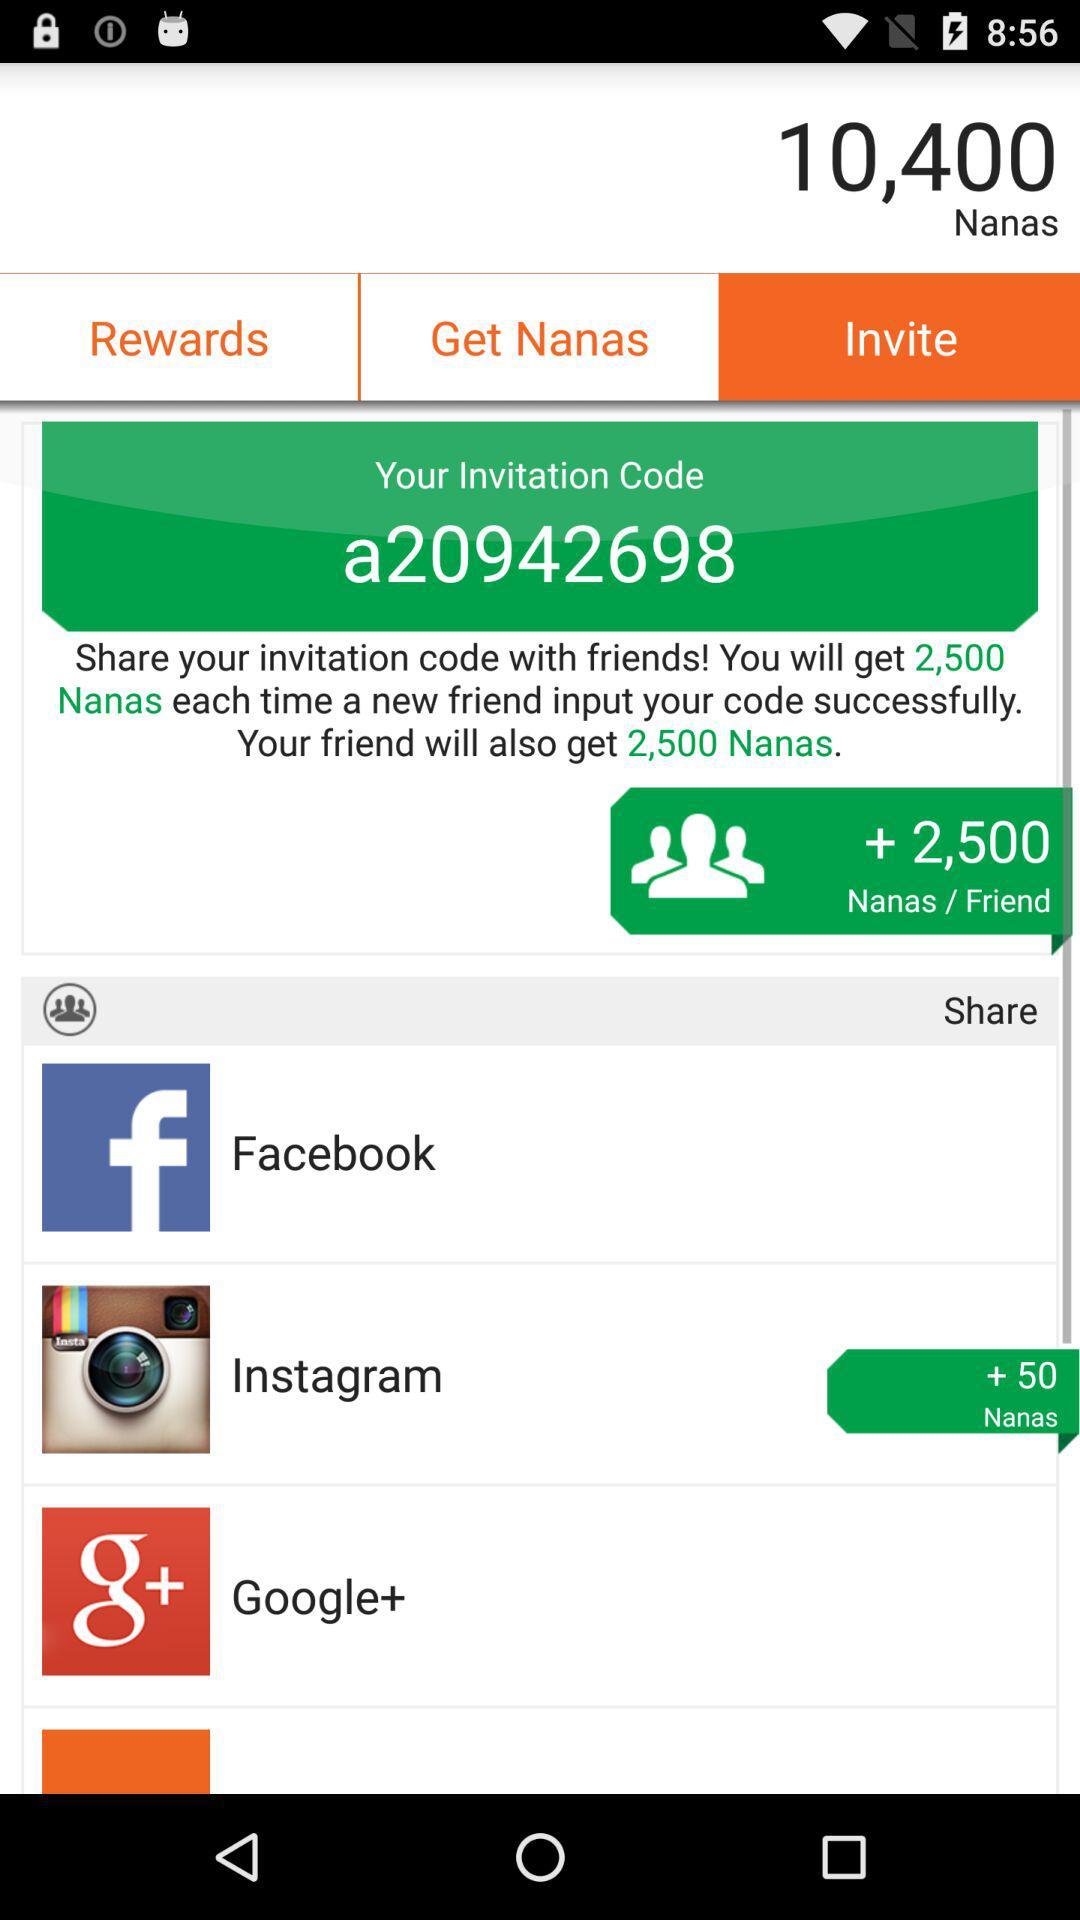How many Nanas does the user get per friend invited?
Answer the question using a single word or phrase. 2,500 